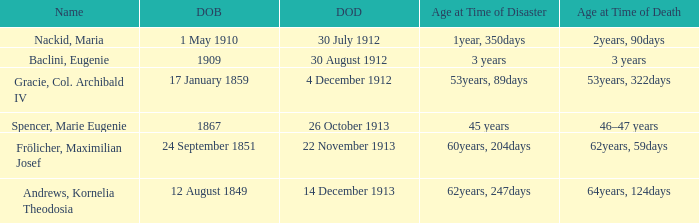How old was the person born 24 September 1851 at the time of disaster? 60years, 204days. 